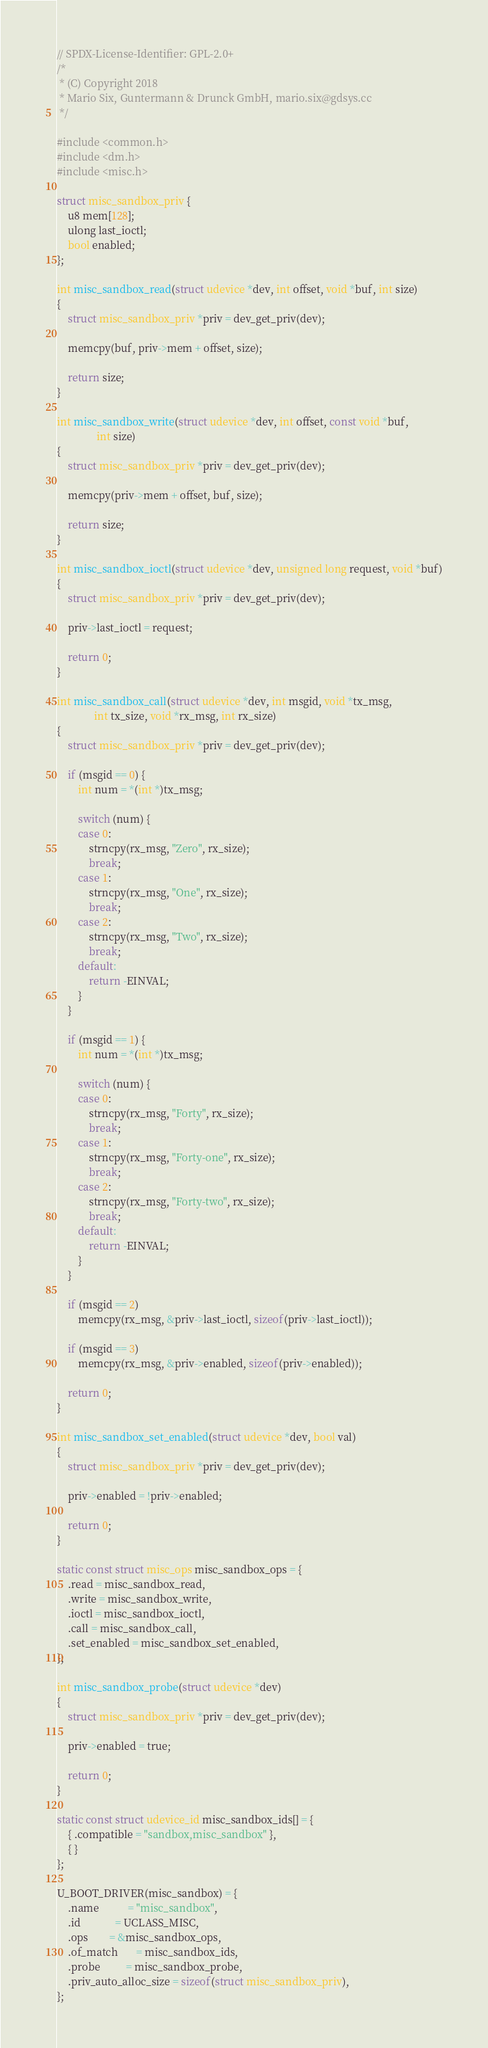<code> <loc_0><loc_0><loc_500><loc_500><_C_>// SPDX-License-Identifier: GPL-2.0+
/*
 * (C) Copyright 2018
 * Mario Six, Guntermann & Drunck GmbH, mario.six@gdsys.cc
 */

#include <common.h>
#include <dm.h>
#include <misc.h>

struct misc_sandbox_priv {
	u8 mem[128];
	ulong last_ioctl;
	bool enabled;
};

int misc_sandbox_read(struct udevice *dev, int offset, void *buf, int size)
{
	struct misc_sandbox_priv *priv = dev_get_priv(dev);

	memcpy(buf, priv->mem + offset, size);

	return size;
}

int misc_sandbox_write(struct udevice *dev, int offset, const void *buf,
		       int size)
{
	struct misc_sandbox_priv *priv = dev_get_priv(dev);

	memcpy(priv->mem + offset, buf, size);

	return size;
}

int misc_sandbox_ioctl(struct udevice *dev, unsigned long request, void *buf)
{
	struct misc_sandbox_priv *priv = dev_get_priv(dev);

	priv->last_ioctl = request;

	return 0;
}

int misc_sandbox_call(struct udevice *dev, int msgid, void *tx_msg,
		      int tx_size, void *rx_msg, int rx_size)
{
	struct misc_sandbox_priv *priv = dev_get_priv(dev);

	if (msgid == 0) {
		int num = *(int *)tx_msg;

		switch (num) {
		case 0:
			strncpy(rx_msg, "Zero", rx_size);
			break;
		case 1:
			strncpy(rx_msg, "One", rx_size);
			break;
		case 2:
			strncpy(rx_msg, "Two", rx_size);
			break;
		default:
			return -EINVAL;
		}
	}

	if (msgid == 1) {
		int num = *(int *)tx_msg;

		switch (num) {
		case 0:
			strncpy(rx_msg, "Forty", rx_size);
			break;
		case 1:
			strncpy(rx_msg, "Forty-one", rx_size);
			break;
		case 2:
			strncpy(rx_msg, "Forty-two", rx_size);
			break;
		default:
			return -EINVAL;
		}
	}

	if (msgid == 2)
		memcpy(rx_msg, &priv->last_ioctl, sizeof(priv->last_ioctl));

	if (msgid == 3)
		memcpy(rx_msg, &priv->enabled, sizeof(priv->enabled));

	return 0;
}

int misc_sandbox_set_enabled(struct udevice *dev, bool val)
{
	struct misc_sandbox_priv *priv = dev_get_priv(dev);

	priv->enabled = !priv->enabled;

	return 0;
}

static const struct misc_ops misc_sandbox_ops = {
	.read = misc_sandbox_read,
	.write = misc_sandbox_write,
	.ioctl = misc_sandbox_ioctl,
	.call = misc_sandbox_call,
	.set_enabled = misc_sandbox_set_enabled,
};

int misc_sandbox_probe(struct udevice *dev)
{
	struct misc_sandbox_priv *priv = dev_get_priv(dev);

	priv->enabled = true;

	return 0;
}

static const struct udevice_id misc_sandbox_ids[] = {
	{ .compatible = "sandbox,misc_sandbox" },
	{ }
};

U_BOOT_DRIVER(misc_sandbox) = {
	.name           = "misc_sandbox",
	.id             = UCLASS_MISC,
	.ops		= &misc_sandbox_ops,
	.of_match       = misc_sandbox_ids,
	.probe          = misc_sandbox_probe,
	.priv_auto_alloc_size = sizeof(struct misc_sandbox_priv),
};
</code> 